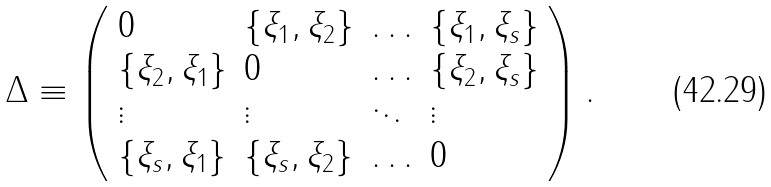<formula> <loc_0><loc_0><loc_500><loc_500>\Delta \equiv \left ( \begin{array} { l l l l } { 0 } & { { \{ \xi _ { 1 } , \xi _ { 2 } \} } } & { \dots } & { { \{ \xi _ { 1 } , \xi _ { s } \} } } \\ { { \{ \xi _ { 2 } , \xi _ { 1 } \} } } & { 0 } & { \dots } & { { \{ \xi _ { 2 } , \xi _ { s } \} } } \\ { \vdots } & { \vdots } & { \ddots } & { \vdots } \\ { { \{ \xi _ { s } , \xi _ { 1 } \} } } & { { \{ \xi _ { s } , \xi _ { 2 } \} } } & { \dots } & { 0 } \end{array} \right ) .</formula> 